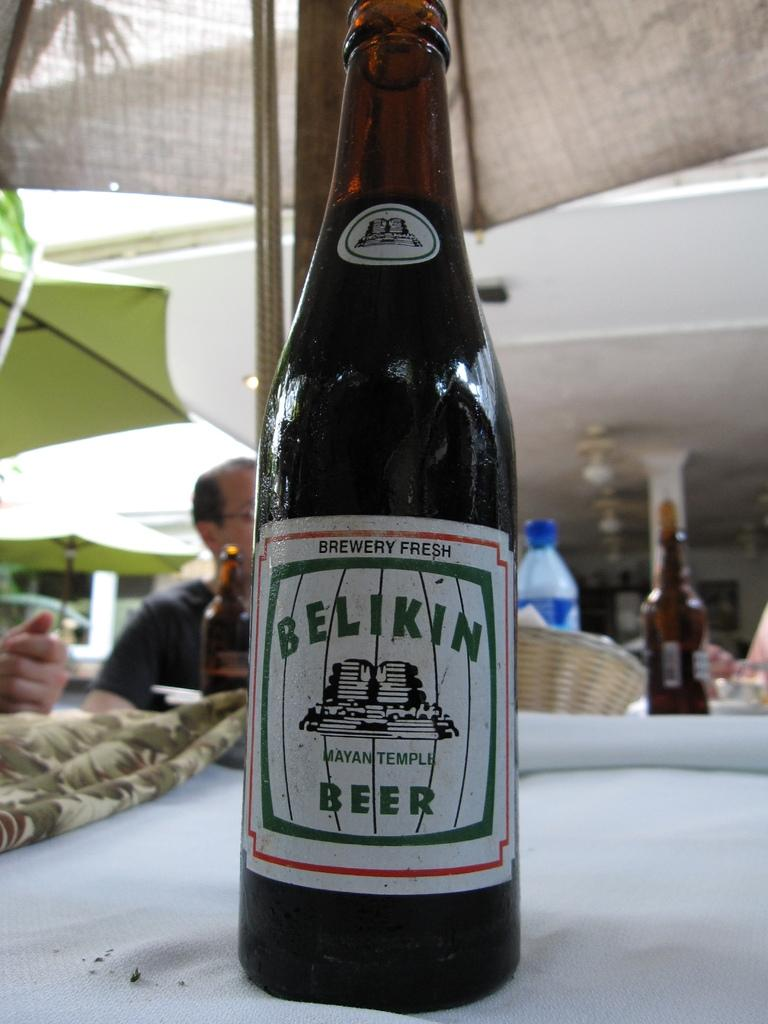What is on the table in the image? There is a wine bottle on the table. Who is present in the image? There is a person sitting in front of the table. What else can be seen on the table besides the wine bottle? There are objects on the table. What is visible above the table in the image? The roof is visible above the table. What type of discovery was made by the kitty in the image? There is no kitty present in the image, so no discovery can be attributed to a kitty. What shape is the heart in the image? There is no heart present in the image. 